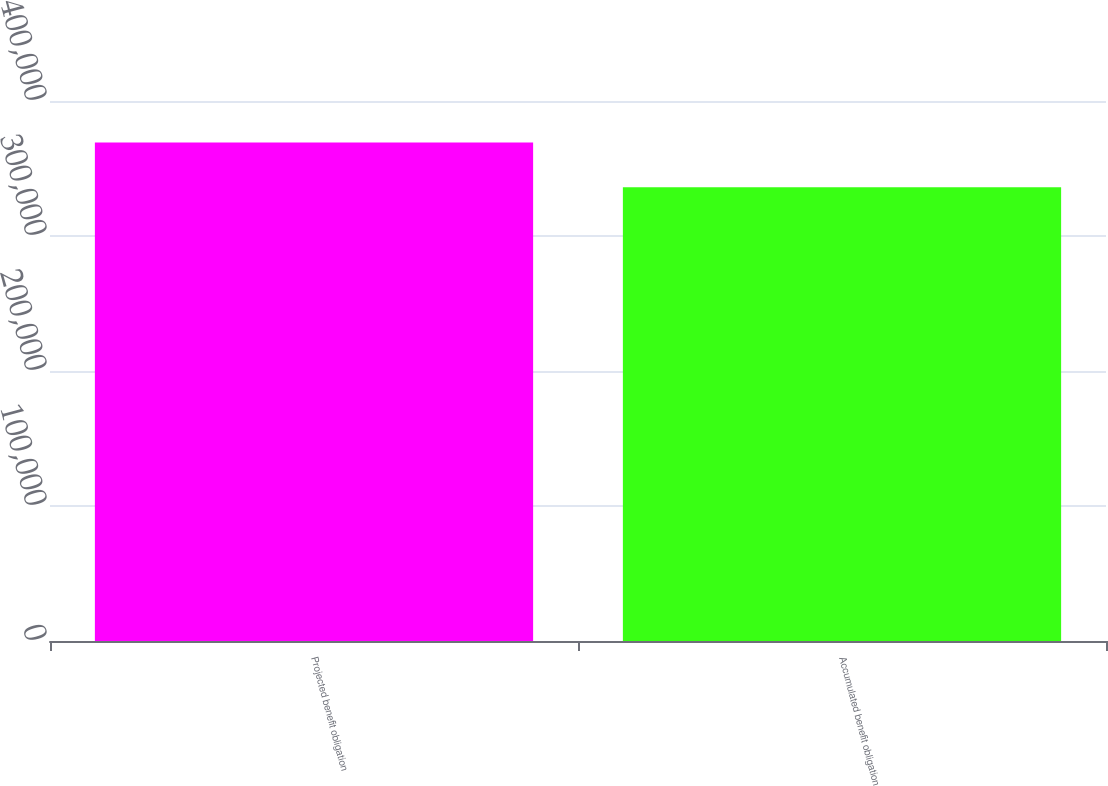<chart> <loc_0><loc_0><loc_500><loc_500><bar_chart><fcel>Projected benefit obligation<fcel>Accumulated benefit obligation<nl><fcel>369289<fcel>336095<nl></chart> 